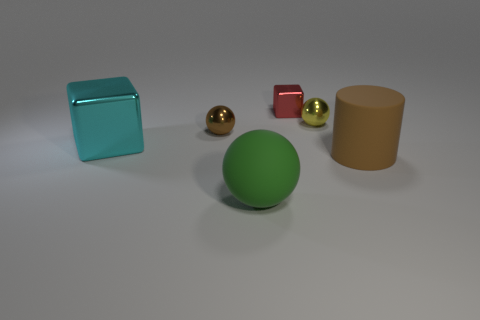There is a small metal cube; is it the same color as the small object that is on the left side of the green ball?
Provide a succinct answer. No. What material is the green object?
Your answer should be compact. Rubber. The small sphere in front of the yellow object is what color?
Provide a succinct answer. Brown. How many matte spheres are the same color as the tiny metal cube?
Keep it short and to the point. 0. How many objects are both behind the cyan metallic cube and to the right of the yellow metallic ball?
Offer a very short reply. 0. The brown rubber thing that is the same size as the cyan metallic block is what shape?
Keep it short and to the point. Cylinder. How big is the brown ball?
Your answer should be compact. Small. What material is the tiny sphere behind the metal ball that is on the left side of the metallic object that is right of the tiny red metallic thing?
Offer a terse response. Metal. What is the color of the cylinder that is the same material as the large ball?
Ensure brevity in your answer.  Brown. There is a rubber thing that is behind the large matte object that is in front of the big cylinder; what number of tiny yellow balls are behind it?
Offer a terse response. 1. 